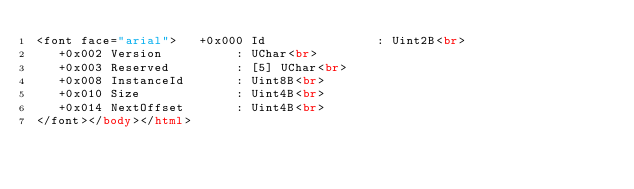<code> <loc_0><loc_0><loc_500><loc_500><_HTML_><font face="arial">   +0x000 Id               : Uint2B<br>
   +0x002 Version          : UChar<br>
   +0x003 Reserved         : [5] UChar<br>
   +0x008 InstanceId       : Uint8B<br>
   +0x010 Size             : Uint4B<br>
   +0x014 NextOffset       : Uint4B<br>
</font></body></html></code> 